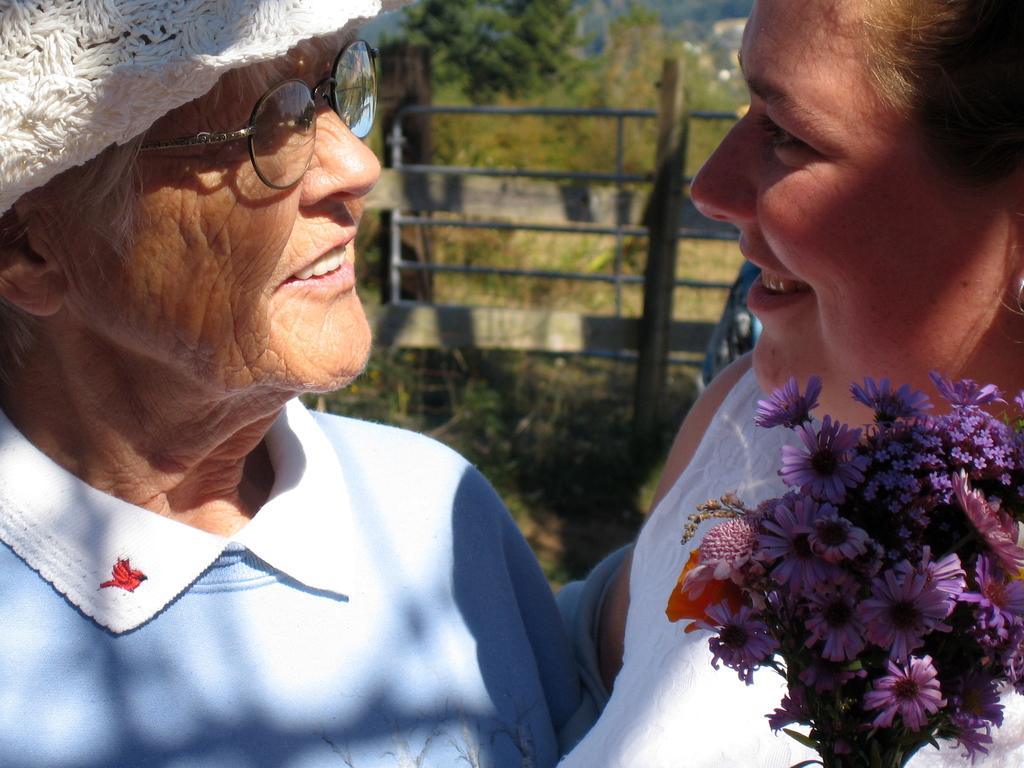What type of flora can be seen in the image? There are flowers in the image. What is the main object in the image? There is a spectacle in the image. What type of material is present in the image? There is cloth in the image. Who is present in the image? There are two women smiling in the image. What can be seen in the background of the image? There is a fence, plants, trees, and some objects in the background of the image. Can you tell me how the stream is flowing in the image? There is no stream present in the image; it features flowers, a spectacle, cloth, two women, a fence, plants, trees, and some objects in the background. What type of decision is being made by the flowers in the image? There are no decisions being made by the flowers in the image, as flowers do not have the ability to make decisions. 